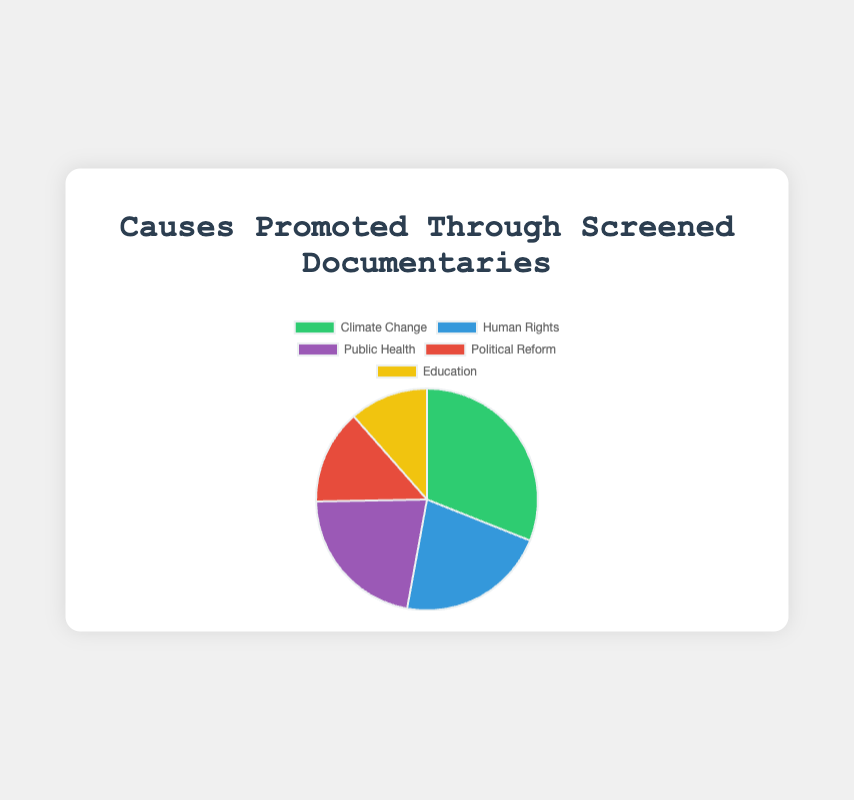What cause has the highest number of screenings, and how many screenings does it have? To find the cause with the highest number of screenings, compare the values for each cause. The data shows that Climate Change has the highest number of screenings, with a total of 27 screenings.
Answer: Climate Change, 27 Which cause has fewer screenings, Education or Political Reform? Comparing the values, Education has a total of 10 screenings (6 + 4), and Political Reform has a total of 12 screenings (5 + 7). Therefore, Education has fewer screenings than Political Reform.
Answer: Education How many more screenings does Climate Change have than Public Health? Climate Change has 27 screenings, and Public Health has 19 screenings. The difference between them is 27 - 19 = 8.
Answer: 8 What is the combined number of screenings for Human Rights and Education causes? Human Rights has 19 screenings (10 + 9), and Education has 10 screenings (6 + 4). The combined number of screenings is 19 + 10 = 29.
Answer: 29 How does the number of screenings for Climate Change compare to that for Human Rights in terms of percentage? Climate Change has 27 screenings and Human Rights has 19. First, find the total number of screenings, which is 27 + 19 + 19 + 12 + 10 = 87. The percentage of Climate Change is (27/87) * 100 ≈ 31.03%, and the percentage for Human Rights is (19/87) * 100 ≈ 21.84%.
Answer: Climate Change: 31.03%, Human Rights: 21.84% Which cause is represented by the yellow segment in the pie chart, and how many screenings does it have? By matching the color description with the provided color scheme, the yellow segment represents Education. It has a total of 10 screenings.
Answer: Education, 10 What is the average number of screenings per cause across all categories? Summing up the total screenings across all categories: 27 (Climate Change) + 19 (Human Rights) + 19 (Public Health) + 12 (Political Reform) + 10 (Education) = 87. With 5 causes, the average is 87/5 = 17.4 screenings.
Answer: 17.4 If you combine screenings from Climate Change and Political Reform, what fraction of the total do they represent? The total number of screenings is 87. Climate Change and Political Reform have 27 + 12 = 39 screenings. The fraction is 39/87, which simplifies to approximately 0.4483, or about 44.83%.
Answer: 44.83% 